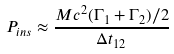<formula> <loc_0><loc_0><loc_500><loc_500>P _ { i n s } \approx \frac { M c ^ { 2 } ( \Gamma _ { 1 } + \Gamma _ { 2 } ) / 2 } { \Delta t _ { 1 2 } }</formula> 